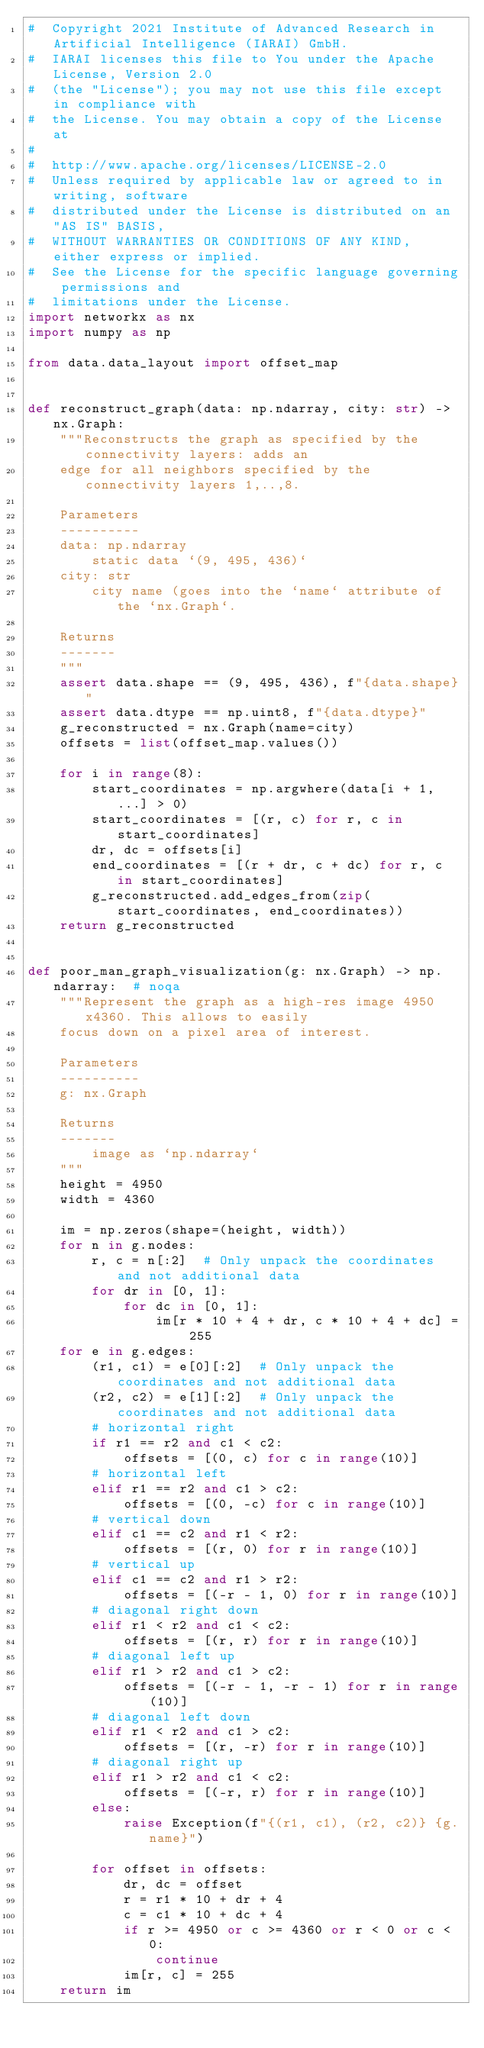<code> <loc_0><loc_0><loc_500><loc_500><_Python_>#  Copyright 2021 Institute of Advanced Research in Artificial Intelligence (IARAI) GmbH.
#  IARAI licenses this file to You under the Apache License, Version 2.0
#  (the "License"); you may not use this file except in compliance with
#  the License. You may obtain a copy of the License at
#
#  http://www.apache.org/licenses/LICENSE-2.0
#  Unless required by applicable law or agreed to in writing, software
#  distributed under the License is distributed on an "AS IS" BASIS,
#  WITHOUT WARRANTIES OR CONDITIONS OF ANY KIND, either express or implied.
#  See the License for the specific language governing permissions and
#  limitations under the License.
import networkx as nx
import numpy as np

from data.data_layout import offset_map


def reconstruct_graph(data: np.ndarray, city: str) -> nx.Graph:
    """Reconstructs the graph as specified by the connectivity layers: adds an
    edge for all neighbors specified by the connectivity layers 1,..,8.

    Parameters
    ----------
    data: np.ndarray
        static data `(9, 495, 436)`
    city: str
        city name (goes into the `name` attribute of the `nx.Graph`.

    Returns
    -------
    """
    assert data.shape == (9, 495, 436), f"{data.shape}"
    assert data.dtype == np.uint8, f"{data.dtype}"
    g_reconstructed = nx.Graph(name=city)
    offsets = list(offset_map.values())

    for i in range(8):
        start_coordinates = np.argwhere(data[i + 1, ...] > 0)
        start_coordinates = [(r, c) for r, c in start_coordinates]
        dr, dc = offsets[i]
        end_coordinates = [(r + dr, c + dc) for r, c in start_coordinates]
        g_reconstructed.add_edges_from(zip(start_coordinates, end_coordinates))
    return g_reconstructed


def poor_man_graph_visualization(g: nx.Graph) -> np.ndarray:  # noqa
    """Represent the graph as a high-res image 4950x4360. This allows to easily
    focus down on a pixel area of interest.

    Parameters
    ----------
    g: nx.Graph

    Returns
    -------
        image as `np.ndarray`
    """
    height = 4950
    width = 4360

    im = np.zeros(shape=(height, width))
    for n in g.nodes:
        r, c = n[:2]  # Only unpack the coordinates and not additional data
        for dr in [0, 1]:
            for dc in [0, 1]:
                im[r * 10 + 4 + dr, c * 10 + 4 + dc] = 255
    for e in g.edges:
        (r1, c1) = e[0][:2]  # Only unpack the coordinates and not additional data
        (r2, c2) = e[1][:2]  # Only unpack the coordinates and not additional data
        # horizontal right
        if r1 == r2 and c1 < c2:
            offsets = [(0, c) for c in range(10)]
        # horizontal left
        elif r1 == r2 and c1 > c2:
            offsets = [(0, -c) for c in range(10)]
        # vertical down
        elif c1 == c2 and r1 < r2:
            offsets = [(r, 0) for r in range(10)]
        # vertical up
        elif c1 == c2 and r1 > r2:
            offsets = [(-r - 1, 0) for r in range(10)]
        # diagonal right down
        elif r1 < r2 and c1 < c2:
            offsets = [(r, r) for r in range(10)]
        # diagonal left up
        elif r1 > r2 and c1 > c2:
            offsets = [(-r - 1, -r - 1) for r in range(10)]
        # diagonal left down
        elif r1 < r2 and c1 > c2:
            offsets = [(r, -r) for r in range(10)]
        # diagonal right up
        elif r1 > r2 and c1 < c2:
            offsets = [(-r, r) for r in range(10)]
        else:
            raise Exception(f"{(r1, c1), (r2, c2)} {g.name}")

        for offset in offsets:
            dr, dc = offset
            r = r1 * 10 + dr + 4
            c = c1 * 10 + dc + 4
            if r >= 4950 or c >= 4360 or r < 0 or c < 0:
                continue
            im[r, c] = 255
    return im
</code> 